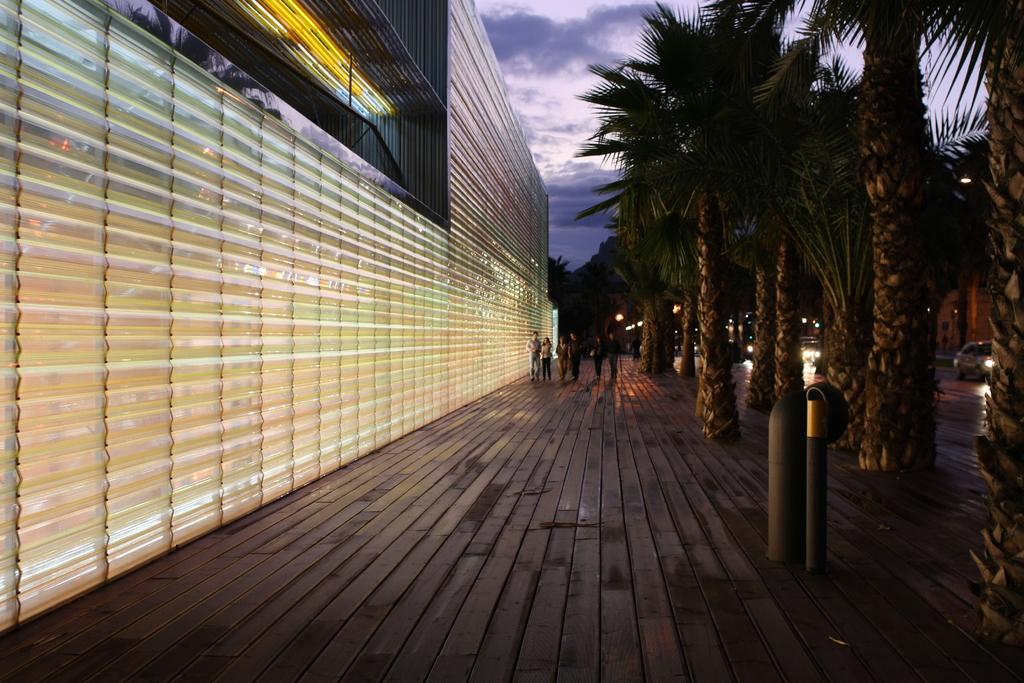Could you give a brief overview of what you see in this image? To the left side of the image there is a building. There are people. To the right side of the image there are trees. There are cars on the road. At the top of the image there is sky. At the bottom of the image there is a pathway. 